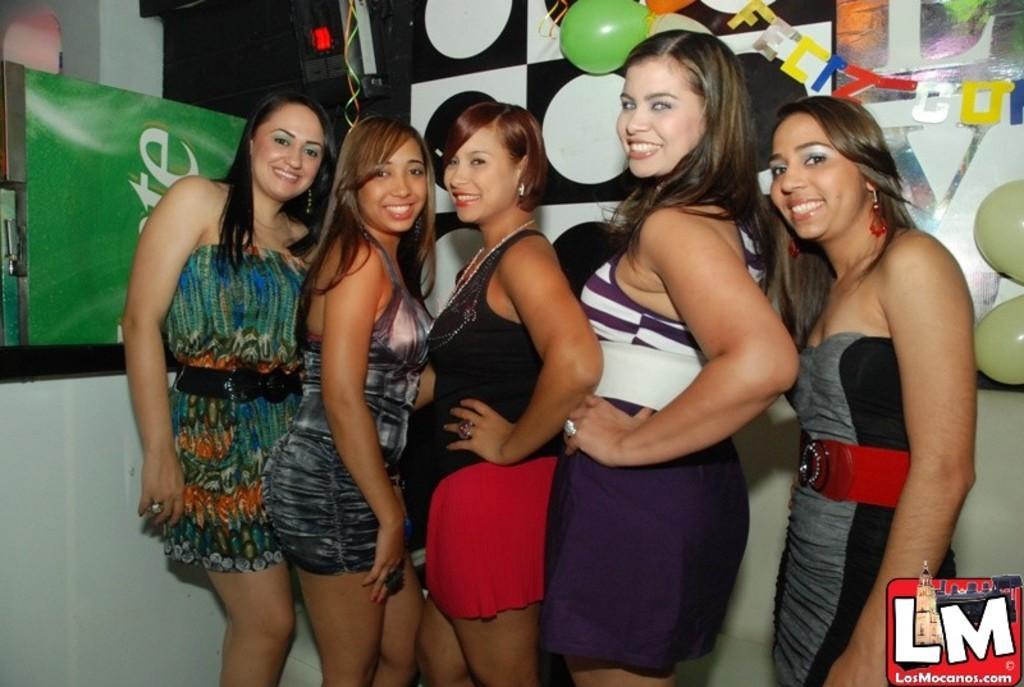How would you summarize this image in a sentence or two? In this image we can see a few people standing and smiling, there are some balloons, machine and some other objects, also we can see the wall and a pillar. 